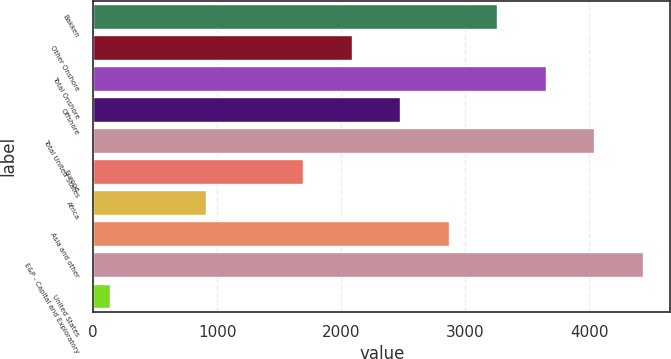Convert chart. <chart><loc_0><loc_0><loc_500><loc_500><bar_chart><fcel>Bakken<fcel>Other Onshore<fcel>Total Onshore<fcel>Offshore<fcel>Total United States<fcel>Europe<fcel>Africa<fcel>Asia and other<fcel>E&P - Capital and Exploratory<fcel>United States<nl><fcel>3260<fcel>2087<fcel>3651<fcel>2478<fcel>4042<fcel>1696<fcel>914<fcel>2869<fcel>4433<fcel>132<nl></chart> 